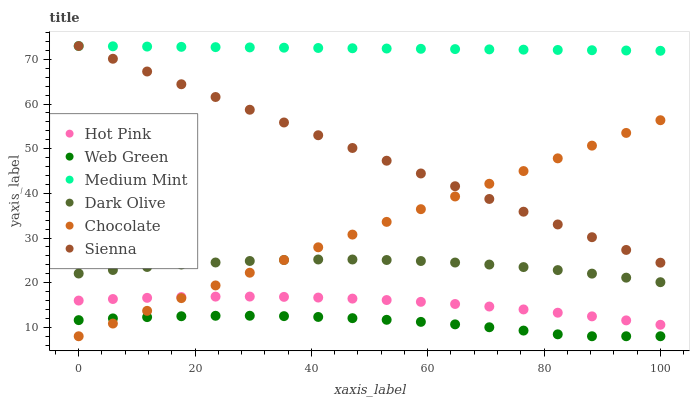Does Web Green have the minimum area under the curve?
Answer yes or no. Yes. Does Medium Mint have the maximum area under the curve?
Answer yes or no. Yes. Does Dark Olive have the minimum area under the curve?
Answer yes or no. No. Does Dark Olive have the maximum area under the curve?
Answer yes or no. No. Is Chocolate the smoothest?
Answer yes or no. Yes. Is Web Green the roughest?
Answer yes or no. Yes. Is Dark Olive the smoothest?
Answer yes or no. No. Is Dark Olive the roughest?
Answer yes or no. No. Does Web Green have the lowest value?
Answer yes or no. Yes. Does Dark Olive have the lowest value?
Answer yes or no. No. Does Sienna have the highest value?
Answer yes or no. Yes. Does Dark Olive have the highest value?
Answer yes or no. No. Is Hot Pink less than Sienna?
Answer yes or no. Yes. Is Sienna greater than Hot Pink?
Answer yes or no. Yes. Does Web Green intersect Chocolate?
Answer yes or no. Yes. Is Web Green less than Chocolate?
Answer yes or no. No. Is Web Green greater than Chocolate?
Answer yes or no. No. Does Hot Pink intersect Sienna?
Answer yes or no. No. 